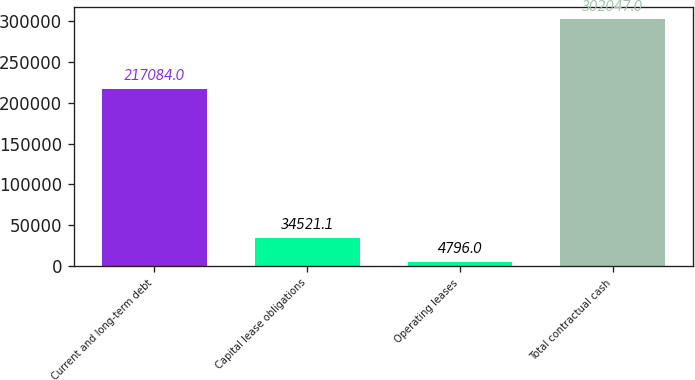<chart> <loc_0><loc_0><loc_500><loc_500><bar_chart><fcel>Current and long-term debt<fcel>Capital lease obligations<fcel>Operating leases<fcel>Total contractual cash<nl><fcel>217084<fcel>34521.1<fcel>4796<fcel>302047<nl></chart> 